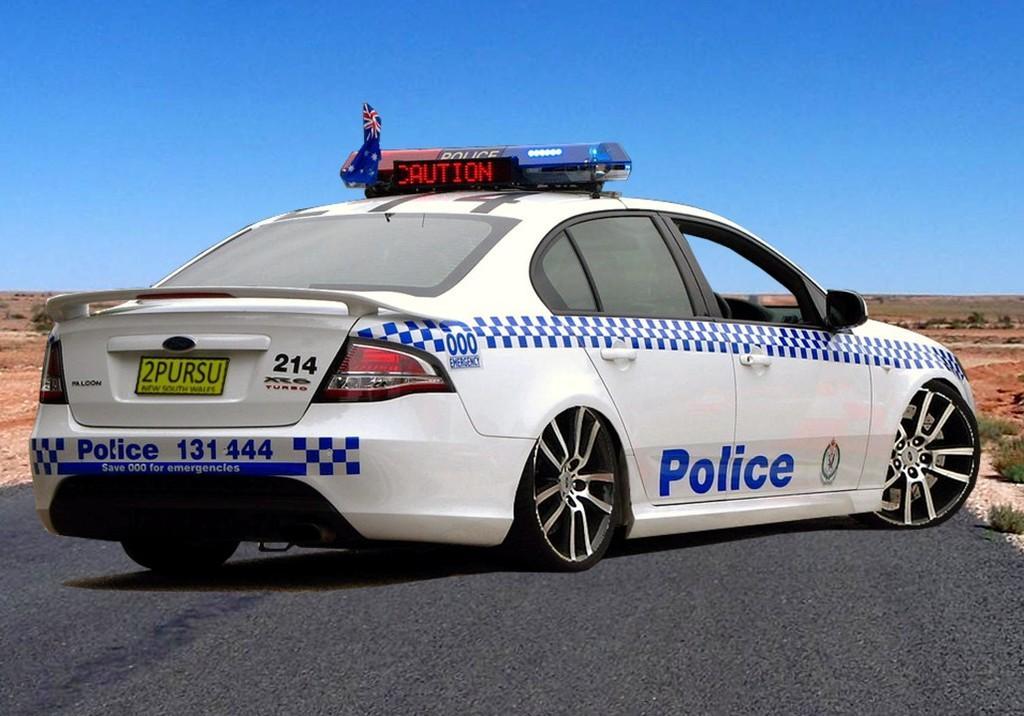Could you give a brief overview of what you see in this image? In this picture there is a police vehicle which is in white and blue color is on the road and there are few plants on either sides of it. 